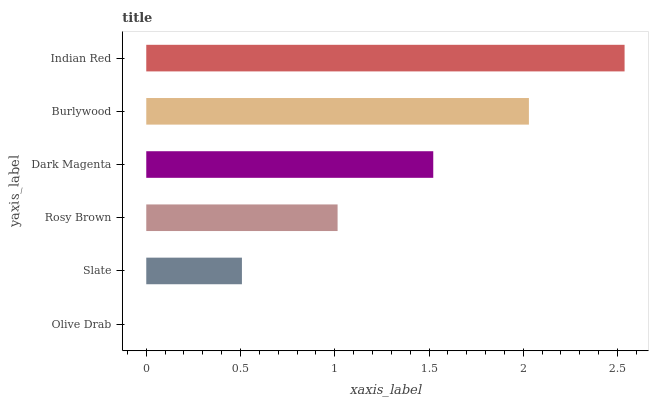Is Olive Drab the minimum?
Answer yes or no. Yes. Is Indian Red the maximum?
Answer yes or no. Yes. Is Slate the minimum?
Answer yes or no. No. Is Slate the maximum?
Answer yes or no. No. Is Slate greater than Olive Drab?
Answer yes or no. Yes. Is Olive Drab less than Slate?
Answer yes or no. Yes. Is Olive Drab greater than Slate?
Answer yes or no. No. Is Slate less than Olive Drab?
Answer yes or no. No. Is Dark Magenta the high median?
Answer yes or no. Yes. Is Rosy Brown the low median?
Answer yes or no. Yes. Is Olive Drab the high median?
Answer yes or no. No. Is Burlywood the low median?
Answer yes or no. No. 